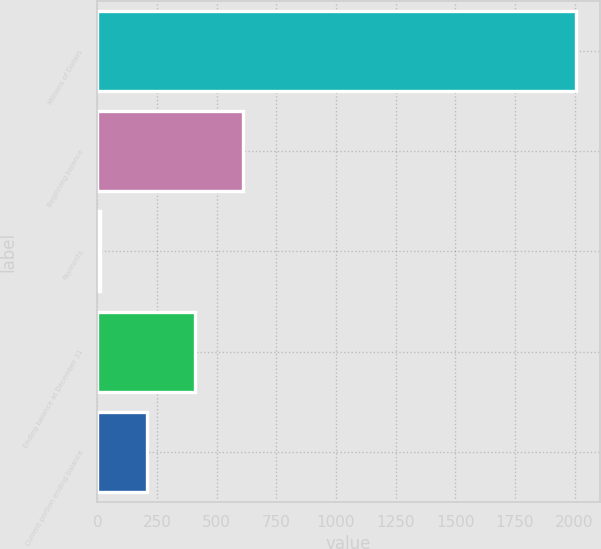<chart> <loc_0><loc_0><loc_500><loc_500><bar_chart><fcel>Millions of Dollars<fcel>Beginning balance<fcel>Payments<fcel>Ending balance at December 31<fcel>Current portion ending balance<nl><fcel>2006<fcel>608.1<fcel>9<fcel>408.4<fcel>208.7<nl></chart> 